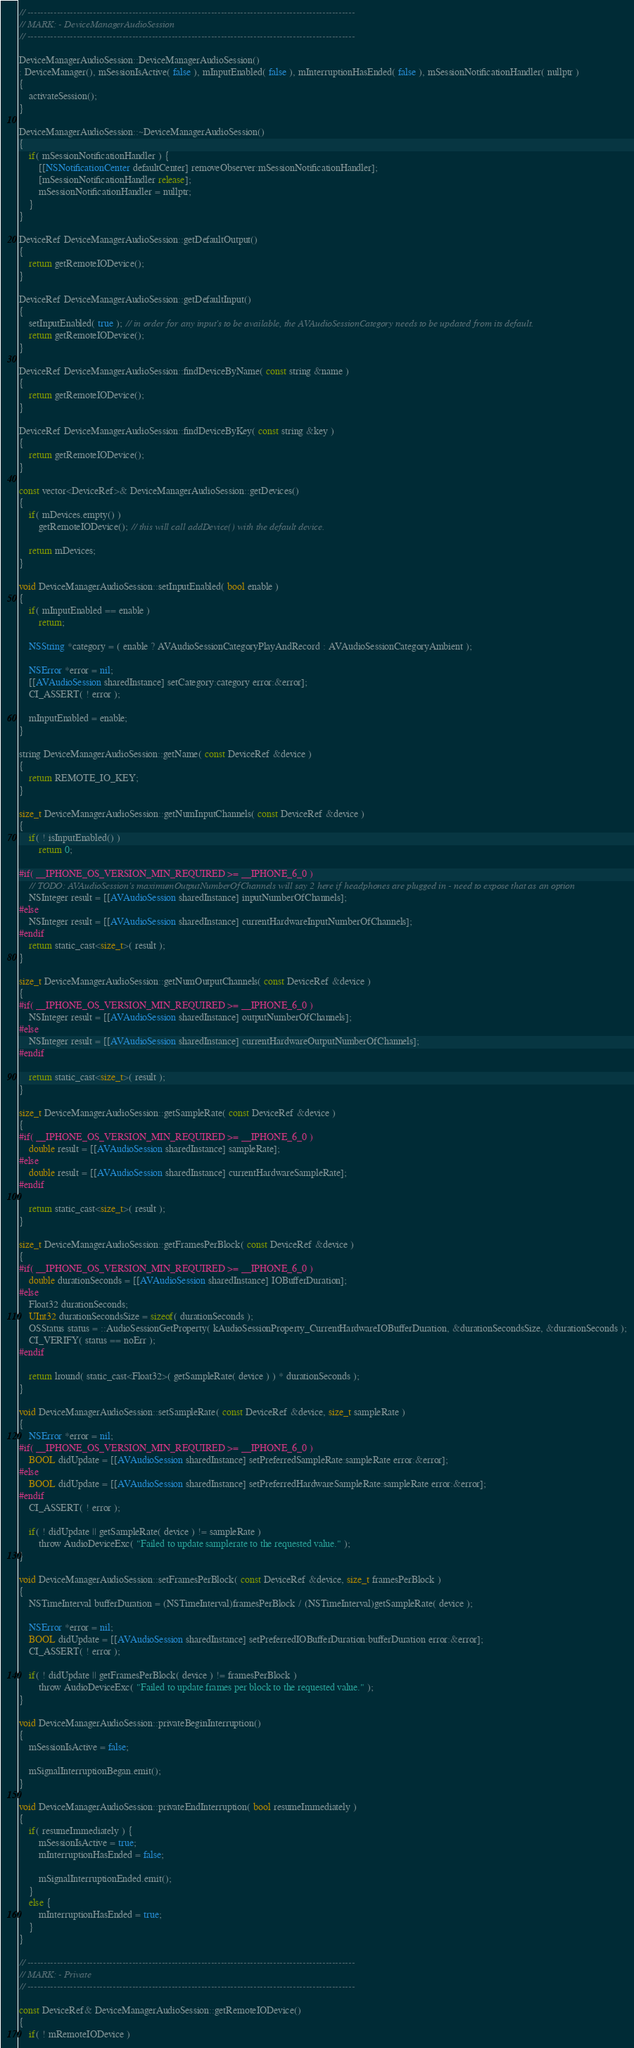<code> <loc_0><loc_0><loc_500><loc_500><_ObjectiveC_>

// ----------------------------------------------------------------------------------------------------
// MARK: - DeviceManagerAudioSession
// ----------------------------------------------------------------------------------------------------

DeviceManagerAudioSession::DeviceManagerAudioSession()
: DeviceManager(), mSessionIsActive( false ), mInputEnabled( false ), mInterruptionHasEnded( false ), mSessionNotificationHandler( nullptr )
{
	activateSession();
}

DeviceManagerAudioSession::~DeviceManagerAudioSession()
{
	if( mSessionNotificationHandler ) {
		[[NSNotificationCenter defaultCenter] removeObserver:mSessionNotificationHandler];
		[mSessionNotificationHandler release];
		mSessionNotificationHandler = nullptr;
	}
}

DeviceRef DeviceManagerAudioSession::getDefaultOutput()
{
	return getRemoteIODevice();
}

DeviceRef DeviceManagerAudioSession::getDefaultInput()
{
	setInputEnabled( true ); // in order for any input's to be available, the AVAudioSessionCategory needs to be updated from its default.
	return getRemoteIODevice();
}

DeviceRef DeviceManagerAudioSession::findDeviceByName( const string &name )
{
	return getRemoteIODevice();
}

DeviceRef DeviceManagerAudioSession::findDeviceByKey( const string &key )
{
	return getRemoteIODevice();
}

const vector<DeviceRef>& DeviceManagerAudioSession::getDevices()
{
	if( mDevices.empty() )
		getRemoteIODevice(); // this will call addDevice() with the default device.
	
	return mDevices;
}

void DeviceManagerAudioSession::setInputEnabled( bool enable )
{
	if( mInputEnabled == enable )
		return;
	
	NSString *category = ( enable ? AVAudioSessionCategoryPlayAndRecord : AVAudioSessionCategoryAmbient );

	NSError *error = nil;
	[[AVAudioSession sharedInstance] setCategory:category error:&error];
	CI_ASSERT( ! error );

	mInputEnabled = enable;
}

string DeviceManagerAudioSession::getName( const DeviceRef &device )
{
	return REMOTE_IO_KEY;
}

size_t DeviceManagerAudioSession::getNumInputChannels( const DeviceRef &device )
{
	if( ! isInputEnabled() )
		return 0;

#if( __IPHONE_OS_VERSION_MIN_REQUIRED >= __IPHONE_6_0 )
	// TODO: AVAudioSession's maximumOutputNumberOfChannels will say 2 here if headphones are plugged in - need to expose that as an option
	NSInteger result = [[AVAudioSession sharedInstance] inputNumberOfChannels];
#else
	NSInteger result = [[AVAudioSession sharedInstance] currentHardwareInputNumberOfChannels];
#endif
	return static_cast<size_t>( result );
}

size_t DeviceManagerAudioSession::getNumOutputChannels( const DeviceRef &device )
{
#if( __IPHONE_OS_VERSION_MIN_REQUIRED >= __IPHONE_6_0 )
	NSInteger result = [[AVAudioSession sharedInstance] outputNumberOfChannels];
#else
	NSInteger result = [[AVAudioSession sharedInstance] currentHardwareOutputNumberOfChannels];
#endif

	return static_cast<size_t>( result );
}

size_t DeviceManagerAudioSession::getSampleRate( const DeviceRef &device )
{
#if( __IPHONE_OS_VERSION_MIN_REQUIRED >= __IPHONE_6_0 )
	double result = [[AVAudioSession sharedInstance] sampleRate];
#else
	double result = [[AVAudioSession sharedInstance] currentHardwareSampleRate];
#endif

	return static_cast<size_t>( result );
}

size_t DeviceManagerAudioSession::getFramesPerBlock( const DeviceRef &device )
{
#if( __IPHONE_OS_VERSION_MIN_REQUIRED >= __IPHONE_6_0 )
	double durationSeconds = [[AVAudioSession sharedInstance] IOBufferDuration];
#else
	Float32 durationSeconds;
	UInt32 durationSecondsSize = sizeof( durationSeconds );
	OSStatus status = ::AudioSessionGetProperty( kAudioSessionProperty_CurrentHardwareIOBufferDuration, &durationSecondsSize, &durationSeconds );
	CI_VERIFY( status == noErr );
#endif

	return lround( static_cast<Float32>( getSampleRate( device ) ) * durationSeconds );
}

void DeviceManagerAudioSession::setSampleRate( const DeviceRef &device, size_t sampleRate )
{
	NSError *error = nil;
#if( __IPHONE_OS_VERSION_MIN_REQUIRED >= __IPHONE_6_0 )
	BOOL didUpdate = [[AVAudioSession sharedInstance] setPreferredSampleRate:sampleRate error:&error];
#else
	BOOL didUpdate = [[AVAudioSession sharedInstance] setPreferredHardwareSampleRate:sampleRate error:&error];
#endif
	CI_ASSERT( ! error );

	if( ! didUpdate || getSampleRate( device ) != sampleRate )
		throw AudioDeviceExc( "Failed to update samplerate to the requested value." );
}

void DeviceManagerAudioSession::setFramesPerBlock( const DeviceRef &device, size_t framesPerBlock )
{
	NSTimeInterval bufferDuration = (NSTimeInterval)framesPerBlock / (NSTimeInterval)getSampleRate( device );

	NSError *error = nil;
	BOOL didUpdate = [[AVAudioSession sharedInstance] setPreferredIOBufferDuration:bufferDuration error:&error];
	CI_ASSERT( ! error );

	if( ! didUpdate || getFramesPerBlock( device ) != framesPerBlock )
		throw AudioDeviceExc( "Failed to update frames per block to the requested value." );
}

void DeviceManagerAudioSession::privateBeginInterruption()
{
	mSessionIsActive = false;

	mSignalInterruptionBegan.emit();
}

void DeviceManagerAudioSession::privateEndInterruption( bool resumeImmediately )
{
	if( resumeImmediately ) {
		mSessionIsActive = true;
		mInterruptionHasEnded = false;

		mSignalInterruptionEnded.emit();
	}
	else {
		mInterruptionHasEnded = true;
	}
}

// ----------------------------------------------------------------------------------------------------
// MARK: - Private
// ----------------------------------------------------------------------------------------------------

const DeviceRef& DeviceManagerAudioSession::getRemoteIODevice()
{
	if( ! mRemoteIODevice )</code> 